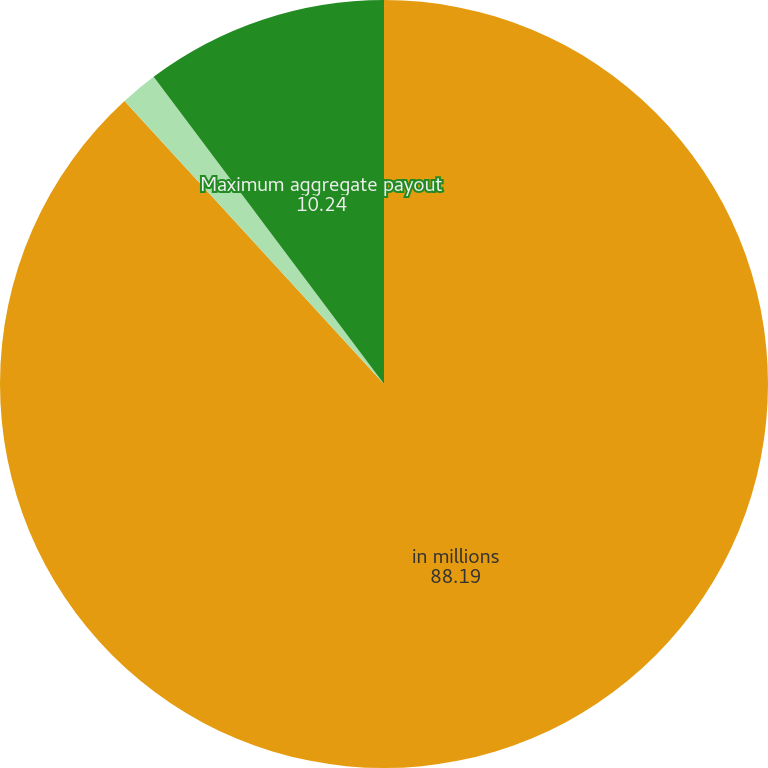Convert chart to OTSL. <chart><loc_0><loc_0><loc_500><loc_500><pie_chart><fcel>in millions<fcel>Minimum aggregate payout<fcel>Maximum aggregate payout<nl><fcel>88.19%<fcel>1.57%<fcel>10.24%<nl></chart> 